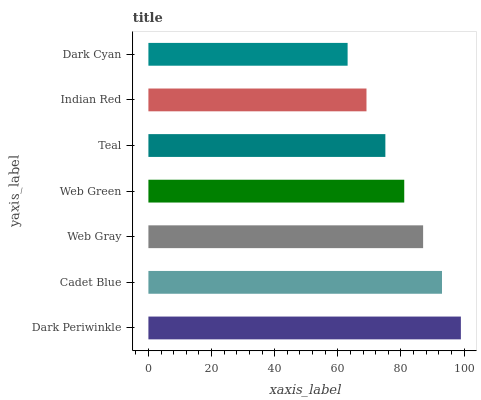Is Dark Cyan the minimum?
Answer yes or no. Yes. Is Dark Periwinkle the maximum?
Answer yes or no. Yes. Is Cadet Blue the minimum?
Answer yes or no. No. Is Cadet Blue the maximum?
Answer yes or no. No. Is Dark Periwinkle greater than Cadet Blue?
Answer yes or no. Yes. Is Cadet Blue less than Dark Periwinkle?
Answer yes or no. Yes. Is Cadet Blue greater than Dark Periwinkle?
Answer yes or no. No. Is Dark Periwinkle less than Cadet Blue?
Answer yes or no. No. Is Web Green the high median?
Answer yes or no. Yes. Is Web Green the low median?
Answer yes or no. Yes. Is Teal the high median?
Answer yes or no. No. Is Dark Cyan the low median?
Answer yes or no. No. 